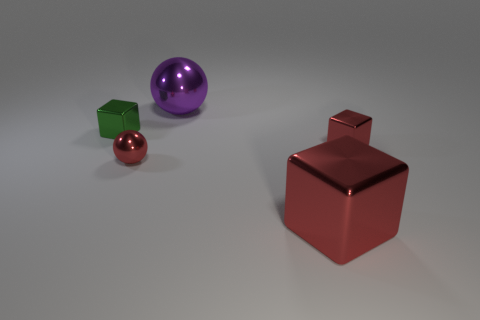Does the big metallic cube have the same color as the small ball?
Offer a very short reply. Yes. Is the color of the tiny shiny block that is right of the purple metallic sphere the same as the big block?
Ensure brevity in your answer.  Yes. There is another small thing that is the same shape as the green thing; what is it made of?
Your answer should be compact. Metal. What number of large green rubber objects are there?
Offer a terse response. 0. The sphere that is behind the small red metal thing that is behind the metallic ball to the left of the large purple shiny sphere is what color?
Ensure brevity in your answer.  Purple. Is the number of yellow rubber objects less than the number of purple metallic things?
Keep it short and to the point. Yes. What color is the other tiny object that is the same shape as the small green metal thing?
Your answer should be compact. Red. There is a big ball that is made of the same material as the tiny green cube; what color is it?
Provide a succinct answer. Purple. How many blue rubber blocks have the same size as the green metal block?
Your answer should be compact. 0. Is the number of red blocks greater than the number of cubes?
Your answer should be compact. No. 